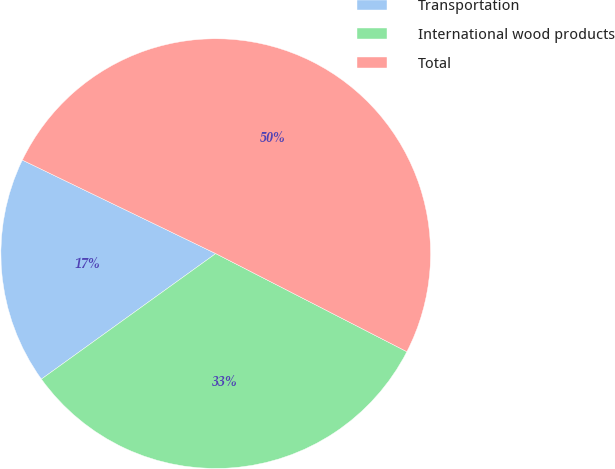Convert chart to OTSL. <chart><loc_0><loc_0><loc_500><loc_500><pie_chart><fcel>Transportation<fcel>International wood products<fcel>Total<nl><fcel>17.1%<fcel>32.52%<fcel>50.38%<nl></chart> 